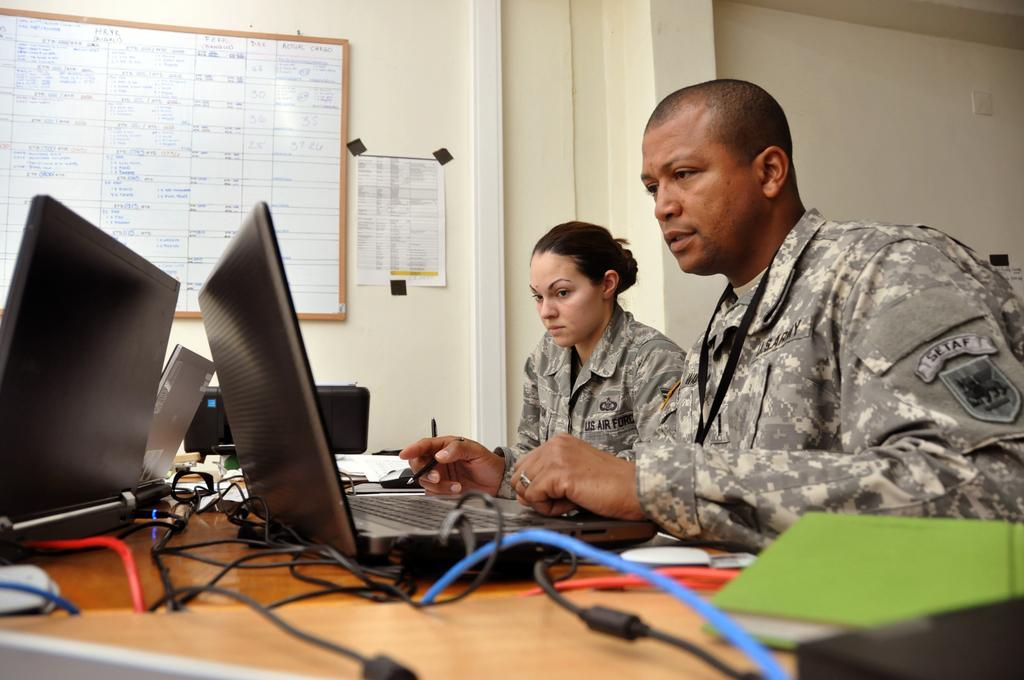<image>
Give a short and clear explanation of the subsequent image. A pair of US Air Force soldiers sit in front of laptops. 